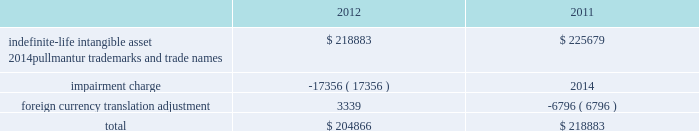Notes to the consolidated financial statements competitive environment and general economic and business conditions , among other factors .
Pullmantur is a brand targeted primarily at the spanish , portu- guese and latin american markets and although pullmantur has diversified its passenger sourcing over the past few years , spain still represents pullmantur 2019s largest market .
As previously disclosed , during 2012 european economies continued to demonstrate insta- bility in light of heightened concerns over sovereign debt issues as well as the impact of proposed auster- ity measures on certain markets .
The spanish econ- omy was more severely impacted than many other economies and there is significant uncertainty as to when it will recover .
In addition , the impact of the costa concordia incident has had a more lingering effect than expected and the impact in future years is uncertain .
These factors were identified in the past as significant risks which could lead to the impairment of pullmantur 2019s goodwill .
More recently , the spanish economy has progressively worsened and forecasts suggest the challenging operating environment will continue for an extended period of time .
The unemployment rate in spain reached 26% ( 26 % ) during the fourth quarter of 2012 and is expected to rise further in 2013 .
The international monetary fund , which had projected gdp growth of 1.8% ( 1.8 % ) a year ago , revised its 2013 gdp projections downward for spain to a contraction of 1.3% ( 1.3 % ) during the fourth quarter of 2012 and further reduced it to a contraction of 1.5% ( 1.5 % ) in january of 2013 .
During the latter half of 2012 new austerity measures , such as increases to the value added tax , cuts to benefits , the phasing out of exemptions and the suspension of government bonuses , were implemented by the spanish government .
We believe these austerity measures are having a larger impact on consumer confidence and discretionary spending than previously anticipated .
As a result , there has been a significant deterioration in bookings from guests sourced from spain during the 2013 wave season .
The combination of all of these factors has caused us to negatively adjust our cash flow projections , especially our closer-in net yield assumptions and the expectations regarding future capacity growth for the brand .
Based on our updated cash flow projections , we determined the implied fair value of goodwill for the pullmantur reporting unit was $ 145.5 million and rec- ognized an impairment charge of $ 319.2 million .
This impairment charge was recognized in earnings during the fourth quarter of 2012 and is reported within impairment of pullmantur related assets within our consolidated statements of comprehensive income ( loss ) .
There have been no goodwill impairment charges related to the pullmantur reporting unit in prior periods .
See note 13 .
Fair value measurements and derivative instruments for further discussion .
If the spanish economy weakens further or recovers more slowly than contemplated or if the economies of other markets ( e.g .
France , brazil , latin america ) perform worse than contemplated in our discounted cash flow model , or if there are material changes to the projected future cash flows used in the impair- ment analyses , especially in net yields , an additional impairment charge of the pullmantur reporting unit 2019s goodwill may be required .
Note 4 .
Intangible assets intangible assets are reported in other assets in our consolidated balance sheets and consist of the follow- ing ( in thousands ) : .
During the fourth quarter of 2012 , we performed the annual impairment review of our trademarks and trade names using a discounted cash flow model and the relief-from-royalty method .
The royalty rate used is based on comparable royalty agreements in the tourism and hospitality industry .
These trademarks and trade names relate to pullmantur and we have used a discount rate comparable to the rate used in valuing the pullmantur reporting unit in our goodwill impairment test .
As described in note 3 .
Goodwill , the continued deterioration of the spanish economy caused us to negatively adjust our cash flow projections for the pullmantur reporting unit , especially our closer-in net yield assumptions and the timing of future capacity growth for the brand .
Based on our updated cash flow projections , we determined that the fair value of pullmantur 2019s trademarks and trade names no longer exceeded their carrying value .
Accordingly , we recog- nized an impairment charge of approximately $ 17.4 million to write down trademarks and trade names to their fair value of $ 204.9 million .
This impairment charge was recognized in earnings during the fourth quarter of 2012 and is reported within impairment of pullmantur related assets within our consolidated statements of comprehensive income ( loss ) .
See note 13 .
Fair value measurements and derivative instruments for further discussion .
If the spanish economy weakens further or recovers more slowly than contemplated or if the economies of other markets ( e.g .
France , brazil , latin america ) 0494.indd 76 3/27/13 12:53 pm .
What was the percentage of the impairment to the trademarks and trade names recog- nized? 
Computations: (17.4 / (17.4 + 204.9))
Answer: 0.07827. 